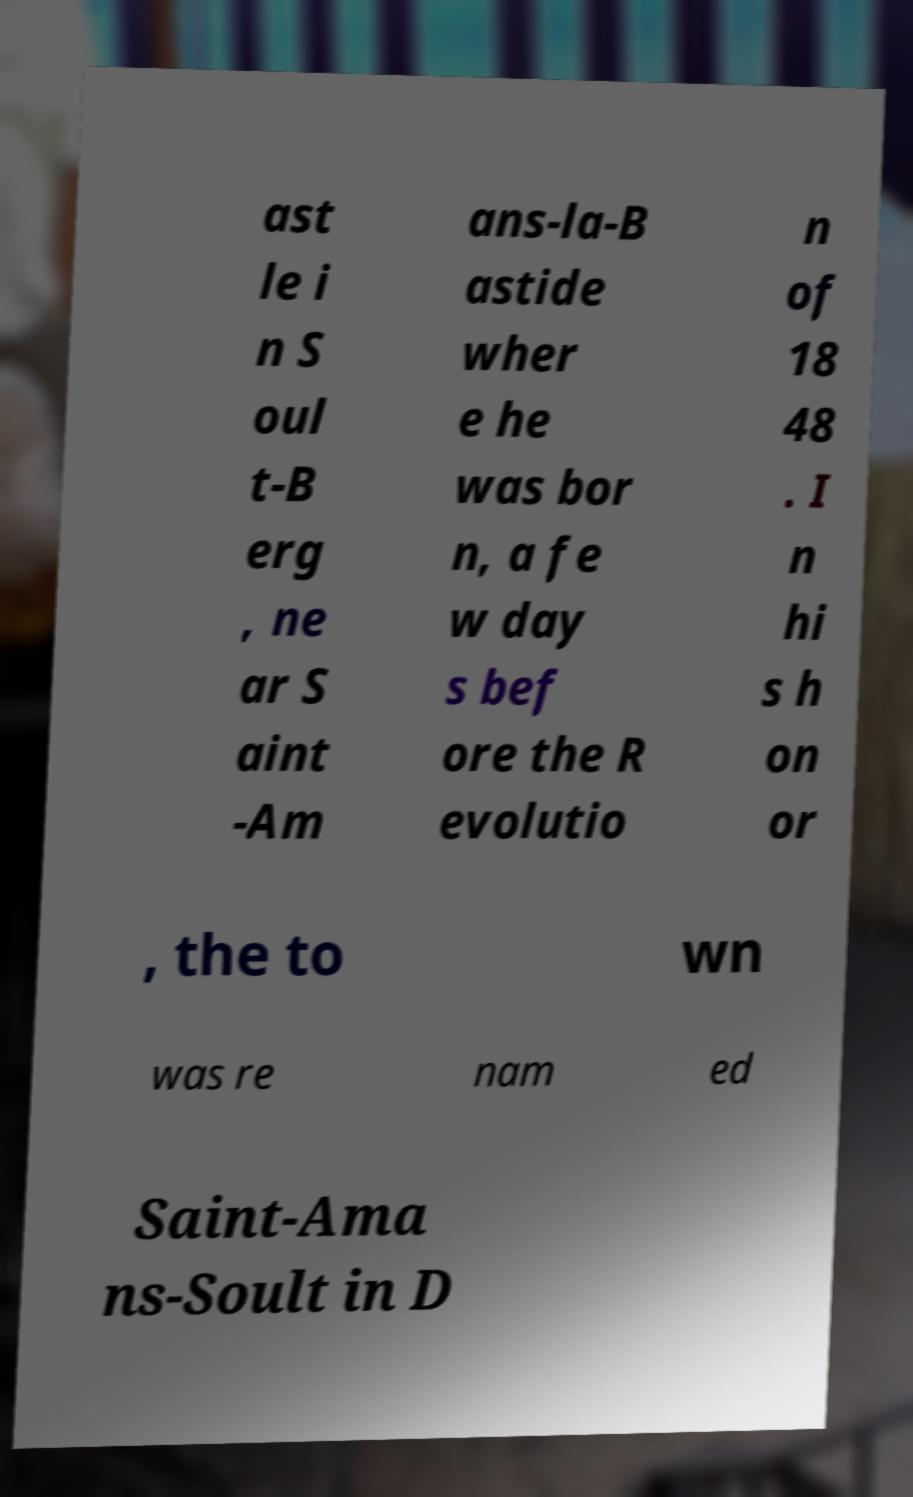Can you read and provide the text displayed in the image?This photo seems to have some interesting text. Can you extract and type it out for me? ast le i n S oul t-B erg , ne ar S aint -Am ans-la-B astide wher e he was bor n, a fe w day s bef ore the R evolutio n of 18 48 . I n hi s h on or , the to wn was re nam ed Saint-Ama ns-Soult in D 